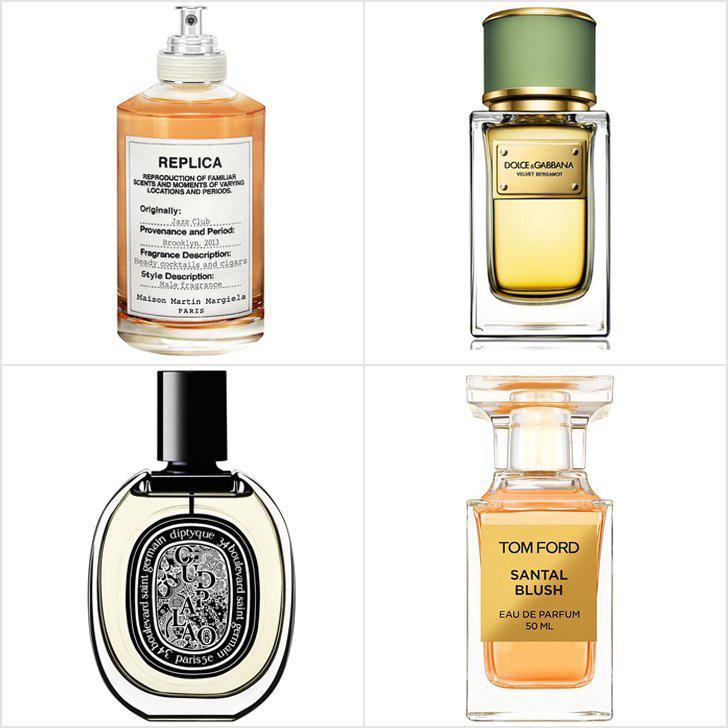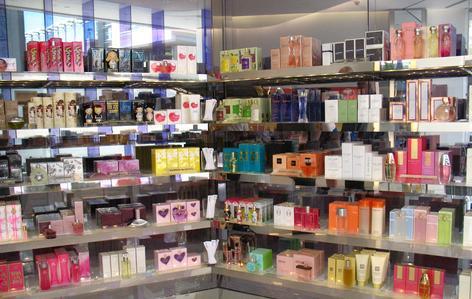The first image is the image on the left, the second image is the image on the right. For the images displayed, is the sentence "There are at most four perfume bottles in the left image." factually correct? Answer yes or no. Yes. The first image is the image on the left, the second image is the image on the right. Analyze the images presented: Is the assertion "One of the images shows a corner area of a shop." valid? Answer yes or no. Yes. 